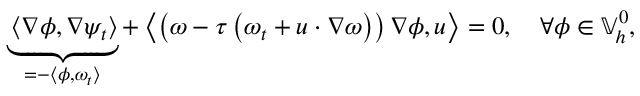<formula> <loc_0><loc_0><loc_500><loc_500>\underbrace { \left \langle \nabla \phi , \nabla \psi _ { t } \right \rangle } _ { = - \left \langle \phi , \omega _ { t } \right \rangle } + \left \langle \left ( \omega - \tau \left ( \omega _ { t } + u \cdot \nabla \omega \right ) \right ) \nabla \phi , u \right \rangle = 0 , \quad \forall \phi \in \mathbb { V } _ { h } ^ { 0 } ,</formula> 